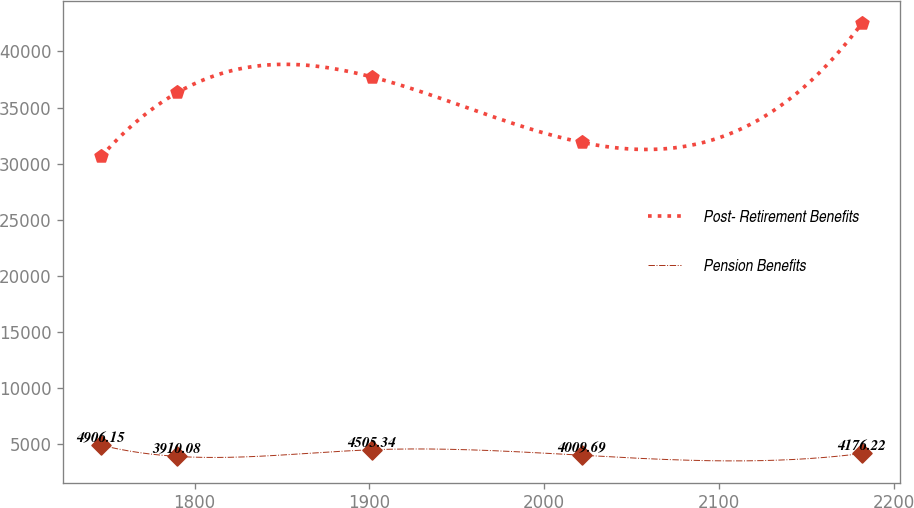Convert chart. <chart><loc_0><loc_0><loc_500><loc_500><line_chart><ecel><fcel>Post- Retirement Benefits<fcel>Pension Benefits<nl><fcel>1746.69<fcel>30649.8<fcel>4906.15<nl><fcel>1790.2<fcel>36345.3<fcel>3910.08<nl><fcel>1901.72<fcel>37715.5<fcel>4505.34<nl><fcel>2021.78<fcel>31886.7<fcel>4009.69<nl><fcel>2181.82<fcel>42540.2<fcel>4176.22<nl></chart> 